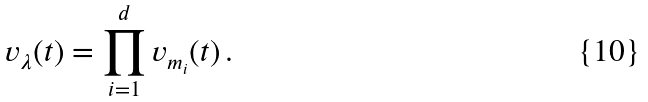<formula> <loc_0><loc_0><loc_500><loc_500>v _ { \lambda } ( t ) = \prod _ { i = 1 } ^ { d } v _ { m _ { i } } ( t ) \, .</formula> 